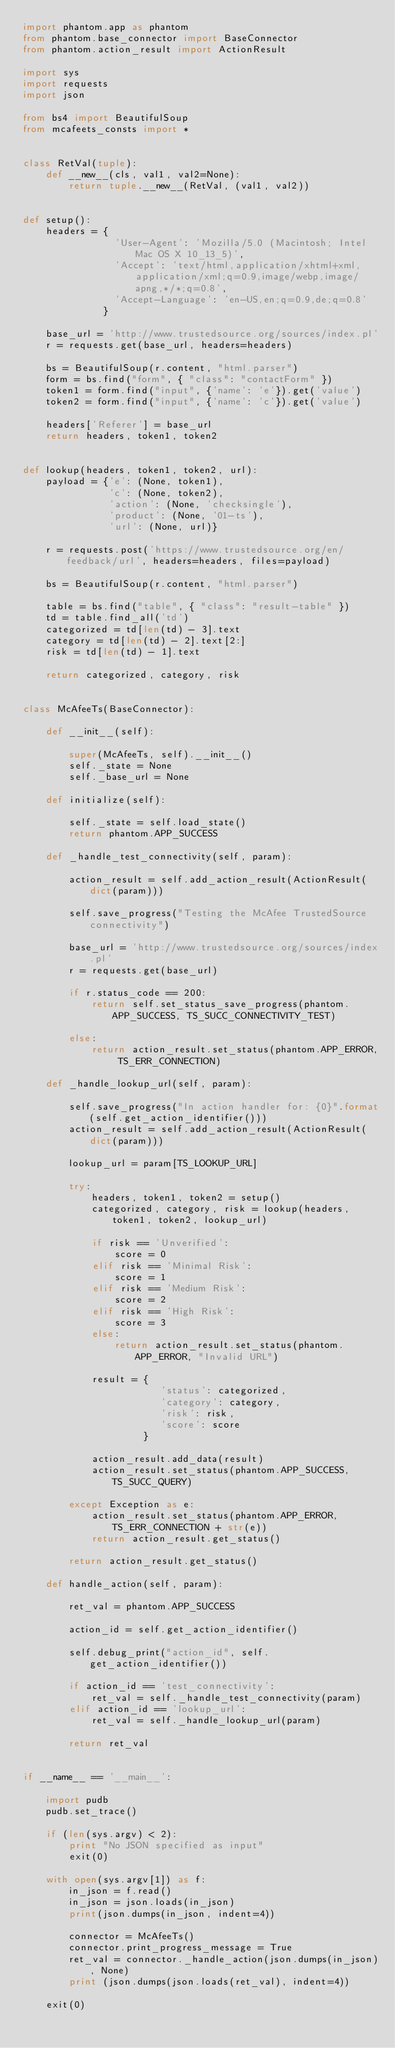Convert code to text. <code><loc_0><loc_0><loc_500><loc_500><_Python_>import phantom.app as phantom
from phantom.base_connector import BaseConnector
from phantom.action_result import ActionResult

import sys
import requests
import json

from bs4 import BeautifulSoup
from mcafeets_consts import *


class RetVal(tuple):
    def __new__(cls, val1, val2=None):
        return tuple.__new__(RetVal, (val1, val2))


def setup():
    headers = {
                'User-Agent': 'Mozilla/5.0 (Macintosh; Intel Mac OS X 10_13_5)',
                'Accept': 'text/html,application/xhtml+xml,application/xml;q=0.9,image/webp,image/apng,*/*;q=0.8',
                'Accept-Language': 'en-US,en;q=0.9,de;q=0.8'
              }

    base_url = 'http://www.trustedsource.org/sources/index.pl'
    r = requests.get(base_url, headers=headers)

    bs = BeautifulSoup(r.content, "html.parser")
    form = bs.find("form", { "class": "contactForm" })
    token1 = form.find("input", {'name': 'e'}).get('value')
    token2 = form.find("input", {'name': 'c'}).get('value')

    headers['Referer'] = base_url
    return headers, token1, token2


def lookup(headers, token1, token2, url):
    payload = {'e': (None, token1),
               'c': (None, token2),
               'action': (None, 'checksingle'),
               'product': (None, '01-ts'),
               'url': (None, url)}

    r = requests.post('https://www.trustedsource.org/en/feedback/url', headers=headers, files=payload)

    bs = BeautifulSoup(r.content, "html.parser")

    table = bs.find("table", { "class": "result-table" })
    td = table.find_all('td')
    categorized = td[len(td) - 3].text
    category = td[len(td) - 2].text[2:]
    risk = td[len(td) - 1].text

    return categorized, category, risk


class McAfeeTs(BaseConnector):

    def __init__(self):

        super(McAfeeTs, self).__init__()
        self._state = None
        self._base_url = None

    def initialize(self):

        self._state = self.load_state()
        return phantom.APP_SUCCESS

    def _handle_test_connectivity(self, param):

        action_result = self.add_action_result(ActionResult(dict(param)))

        self.save_progress("Testing the McAfee TrustedSource connectivity")

        base_url = 'http://www.trustedsource.org/sources/index.pl'
        r = requests.get(base_url)

        if r.status_code == 200:
            return self.set_status_save_progress(phantom.APP_SUCCESS, TS_SUCC_CONNECTIVITY_TEST)

        else:
            return action_result.set_status(phantom.APP_ERROR, TS_ERR_CONNECTION)

    def _handle_lookup_url(self, param):

        self.save_progress("In action handler for: {0}".format(self.get_action_identifier()))
        action_result = self.add_action_result(ActionResult(dict(param)))

        lookup_url = param[TS_LOOKUP_URL]

        try:
            headers, token1, token2 = setup()
            categorized, category, risk = lookup(headers, token1, token2, lookup_url)

            if risk == 'Unverified':
                score = 0
            elif risk == 'Minimal Risk':
                score = 1
            elif risk == 'Medium Risk':
                score = 2
            elif risk == 'High Risk':
                score = 3
            else:
                return action_result.set_status(phantom.APP_ERROR, "Invalid URL")

            result = {
                        'status': categorized,
                        'category': category,
                        'risk': risk,
                        'score': score
                     }

            action_result.add_data(result)
            action_result.set_status(phantom.APP_SUCCESS, TS_SUCC_QUERY)

        except Exception as e:
            action_result.set_status(phantom.APP_ERROR, TS_ERR_CONNECTION + str(e))
            return action_result.get_status()

        return action_result.get_status()

    def handle_action(self, param):

        ret_val = phantom.APP_SUCCESS

        action_id = self.get_action_identifier()

        self.debug_print("action_id", self.get_action_identifier())

        if action_id == 'test_connectivity':
            ret_val = self._handle_test_connectivity(param)
        elif action_id == 'lookup_url':
            ret_val = self._handle_lookup_url(param)

        return ret_val


if __name__ == '__main__':

    import pudb
    pudb.set_trace()

    if (len(sys.argv) < 2):
        print "No JSON specified as input"
        exit(0)

    with open(sys.argv[1]) as f:
        in_json = f.read()
        in_json = json.loads(in_json)
        print(json.dumps(in_json, indent=4))

        connector = McAfeeTs()
        connector.print_progress_message = True
        ret_val = connector._handle_action(json.dumps(in_json), None)
        print (json.dumps(json.loads(ret_val), indent=4))

    exit(0)
</code> 